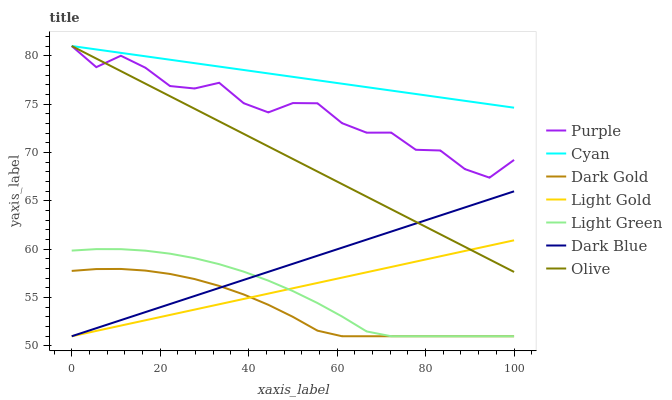Does Dark Gold have the minimum area under the curve?
Answer yes or no. Yes. Does Cyan have the maximum area under the curve?
Answer yes or no. Yes. Does Purple have the minimum area under the curve?
Answer yes or no. No. Does Purple have the maximum area under the curve?
Answer yes or no. No. Is Light Gold the smoothest?
Answer yes or no. Yes. Is Purple the roughest?
Answer yes or no. Yes. Is Dark Blue the smoothest?
Answer yes or no. No. Is Dark Blue the roughest?
Answer yes or no. No. Does Dark Gold have the lowest value?
Answer yes or no. Yes. Does Purple have the lowest value?
Answer yes or no. No. Does Cyan have the highest value?
Answer yes or no. Yes. Does Dark Blue have the highest value?
Answer yes or no. No. Is Dark Blue less than Cyan?
Answer yes or no. Yes. Is Olive greater than Light Green?
Answer yes or no. Yes. Does Cyan intersect Olive?
Answer yes or no. Yes. Is Cyan less than Olive?
Answer yes or no. No. Is Cyan greater than Olive?
Answer yes or no. No. Does Dark Blue intersect Cyan?
Answer yes or no. No. 